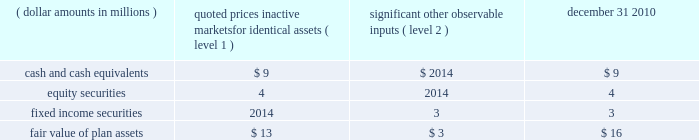1 2 4 n o t e s effective january 1 , 2011 , all u.s .
Employees , including u.s .
Legacy bgi employees , will participate in the brsp .
All plan assets in the two legacy bgi plans , including the 401k plan and retirement plan ( see below ) , were merged into the brsp on january 1 , 2011 .
Under the combined brsp , employee contributions of up to 8% ( 8 % ) of eligible compensation , as defined by the plan and subject to irc limitations , will be matched by the company at 50% ( 50 % ) .
In addition , the company will continue to make an annual retirement contribution to eligible participants equal to 3-5% ( 3-5 % ) of eligible compensation .
Blackrock institutional trust company 401 ( k ) savings plan ( formerly the bgi 401 ( k ) savings plan ) the company assumed a 401 ( k ) plan ( the 201cbgi plan 201d ) covering employees of former bgi as a result of the bgi transaction .
As part of the bgi plan , employee contributions for participants with at least one year of service were matched at 200% ( 200 % ) of participants 2019 pre-tax contributions up to 2% ( 2 % ) of base salary and overtime , and matched 100% ( 100 % ) of the next 2% ( 2 % ) of base salary and overtime , as defined by the plan and subject to irc limitations .
The maximum matching contribution a participant would have received is an amount equal to 6% ( 6 % ) of base salary up to the irc limitations .
The bgi plan expense was $ 12 million for the year ended december 31 , 2010 and immaterial to the company 2019s consolidated financial statements for the year ended december 31 , 2009 .
Effective january 1 , 2011 , the net assets of this plan merged into the brsp .
Blackrock institutional trust company retirement plan ( formerly the bgi retirement plan ) the company assumed a defined contribution money purchase pension plan ( 201cbgi retirement plan 201d ) as a result of the bgi transaction .
All salaried employees of former bgi and its participating affiliates who were u.s .
Residents on the u.s .
Payroll were eligible to participate .
For participants earning less than $ 100000 in base salary , the company contributed 6% ( 6 % ) of a participant 2019s total compensation ( base salary , overtime and performance bonus ) up to $ 100000 .
For participants earning $ 100000 or more in base salary , the company contributed 6% ( 6 % ) of a participant 2019s base salary and overtime up to the irc limita- tion of $ 245000 in 2010 .
These contributions were 25% ( 25 % ) vested once the participant has completed two years of service and then vested at a rate of 25% ( 25 % ) for each additional year of service completed .
Employees with five or more years of service under the retirement plan were 100% ( 100 % ) vested in their entire balance .
The retirement plan expense was $ 13 million for the year ended december 31 , 2010 and immaterial to the company 2019s consolidated financial statements for the year ended december 31 , 2009 .
Effective january 1 , 2011 , the net assets of this plan merged into the brsp .
Blackrock group personal pension plan blackrock investment management ( uk ) limited ( 201cbim 201d ) , a wholly-owned subsidiary of the company , contributes to the blackrock group personal pension plan , a defined contribution plan for all employees of bim .
Bim contributes between 6% ( 6 % ) and 15% ( 15 % ) of each employee 2019s eligible compensation .
The expense for this plan was $ 22 million , $ 13 million and $ 16 million for the years ended december 31 , 2010 , 2009 and 2008 , respectively .
Defined benefit plans in 2009 , prior to the bgi transaction , the company had several defined benefit pension plans in japan , germany , luxembourg and jersey .
All accrued benefits under these defined benefit plans are currently frozen and the plans are closed to new participants .
In 2008 , the defined benefit pension values in luxembourg were transferred into a new defined contribution plan for such employees , removing future liabilities .
Participant benefits under the plans will not change with salary increases or additional years of service .
Through the bgi transaction , the company assumed defined benefit pension plans in japan and germany which are closed to new participants .
During 2010 , these plans merged into the legacy blackrock plans in japan ( the 201cjapan plan 201d ) and germany .
At december 31 , 2010 and 2009 , the plan assets for these plans were approximately $ 19 million and $ 10 million , respectively , and the unfunded obligations were less than $ 6 million and $ 3 million , respectively , which were recorded in accrued compensation and benefits on the consolidated statements of financial condition .
Benefit payments for the next five years and in aggregate for the five years thereafter are not expected to be material .
Defined benefit plan assets for the japan plan of approximately $ 16 million are invested using a total return investment approach whereby a mix of equity securities , debt securities and other investments are used to preserve asset values , diversify risk and achieve the target investment return benchmark .
Investment strategies and asset allocations are based on consideration of plan liabilities and the funded status of the plan .
Investment performance and asset allocation are measured and monitored on an ongoing basis .
The current target allocations for the plan assets are 45-50% ( 45-50 % ) for u.s .
And international equity securities , 50-55% ( 50-55 % ) for u.s .
And international fixed income securities and 0-5% ( 0-5 % ) for cash and cash equivalents .
The table below provides the fair value of the defined benefit japan plan assets at december 31 , 2010 by asset category .
The table also identifies the level of inputs used to determine the fair value of assets in each category .
Quoted prices significant in active other markets for observable identical assets inputs december 31 , ( dollar amounts in millions ) ( level 1 ) ( level 2 ) 2010 .
The assets and unfunded obligation for the defined benefit pension plan in germany and jersey were immaterial to the company 2019s consolidated financial statements at december 31 , 2010 .
Post-retirement benefit plans prior to the bgi transaction , the company had requirements to deliver post-retirement medical benefits to a closed population based in the united kingdom and through the bgi transaction , the company assumed a post-retirement benefit plan to a closed population of former bgi employees in the united kingdom .
For the years ended december 31 , 2010 , 2009 and 2008 , expenses and unfunded obligations for these benefits were immaterial to the company 2019s consolidated financial statements .
In addition , through the bgi transaction , the company assumed a requirement to deliver post-retirement medical benefits to a .
What are the level 2 significant other observable inputs for the fair value of plan assets as a percentage of quoted prices significant in active other markets for observable identical assets inputs as of december 31 , 2010? 
Computations: (3 / 16)
Answer: 0.1875. 